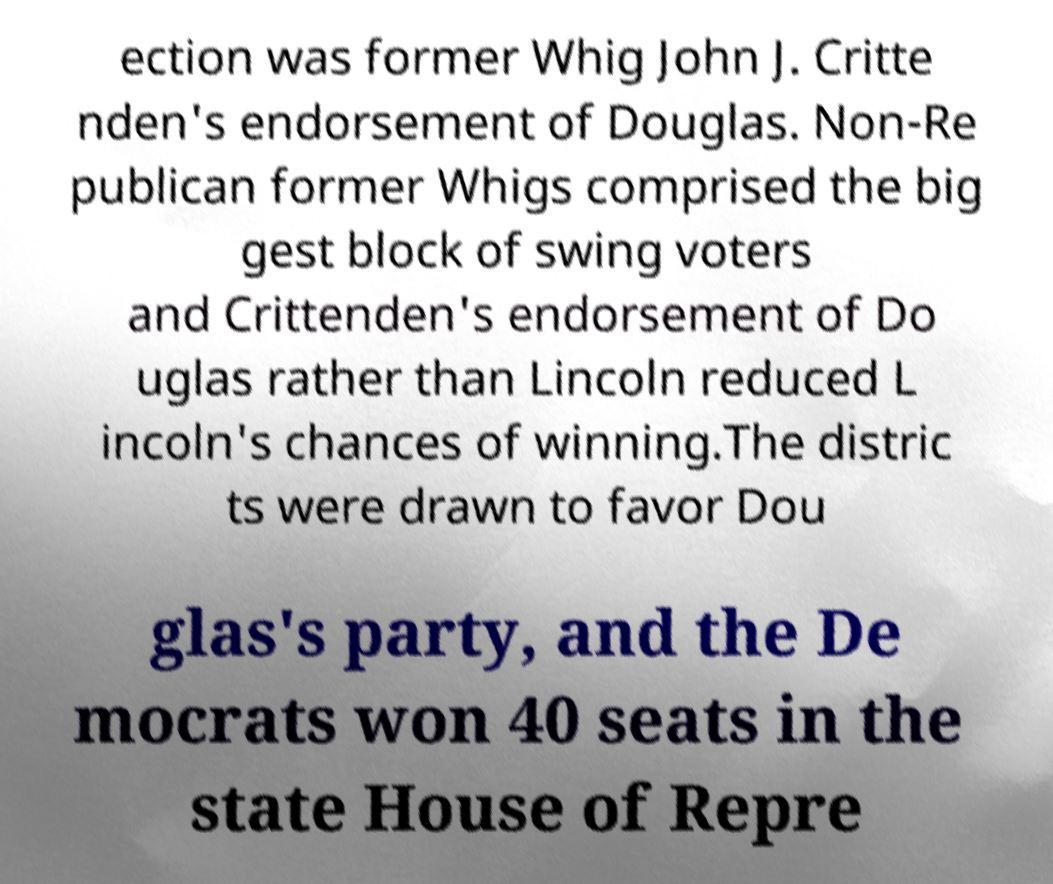Can you read and provide the text displayed in the image?This photo seems to have some interesting text. Can you extract and type it out for me? ection was former Whig John J. Critte nden's endorsement of Douglas. Non-Re publican former Whigs comprised the big gest block of swing voters and Crittenden's endorsement of Do uglas rather than Lincoln reduced L incoln's chances of winning.The distric ts were drawn to favor Dou glas's party, and the De mocrats won 40 seats in the state House of Repre 